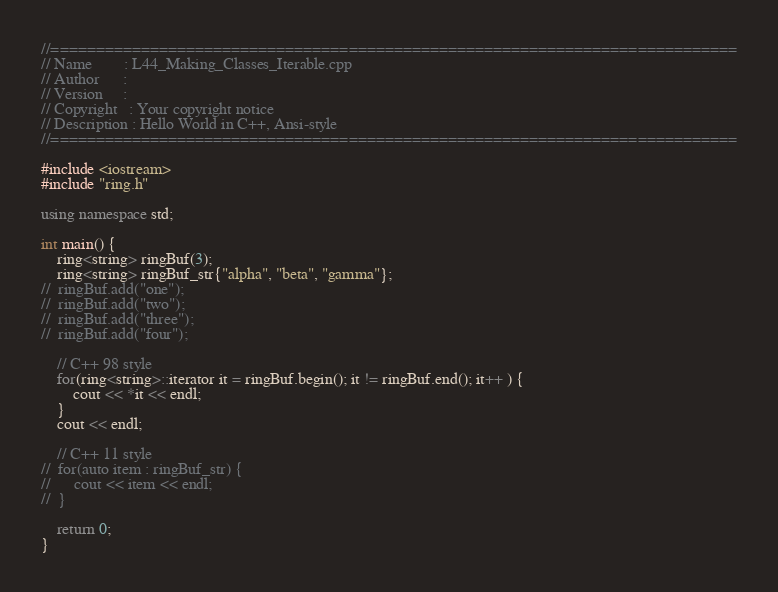<code> <loc_0><loc_0><loc_500><loc_500><_C++_>//============================================================================
// Name        : L44_Making_Classes_Iterable.cpp
// Author      : 
// Version     :
// Copyright   : Your copyright notice
// Description : Hello World in C++, Ansi-style
//============================================================================

#include <iostream>
#include "ring.h"

using namespace std;

int main() {
	ring<string> ringBuf(3);
	ring<string> ringBuf_str{"alpha", "beta", "gamma"};
//	ringBuf.add("one");
//	ringBuf.add("two");
//	ringBuf.add("three");
//	ringBuf.add("four");

	// C++ 98 style
	for(ring<string>::iterator it = ringBuf.begin(); it != ringBuf.end(); it++ ) {
		cout << *it << endl;
	}
	cout << endl;

	// C++ 11 style
//	for(auto item : ringBuf_str) {
//		cout << item << endl;
//	}

	return 0;
}
</code> 